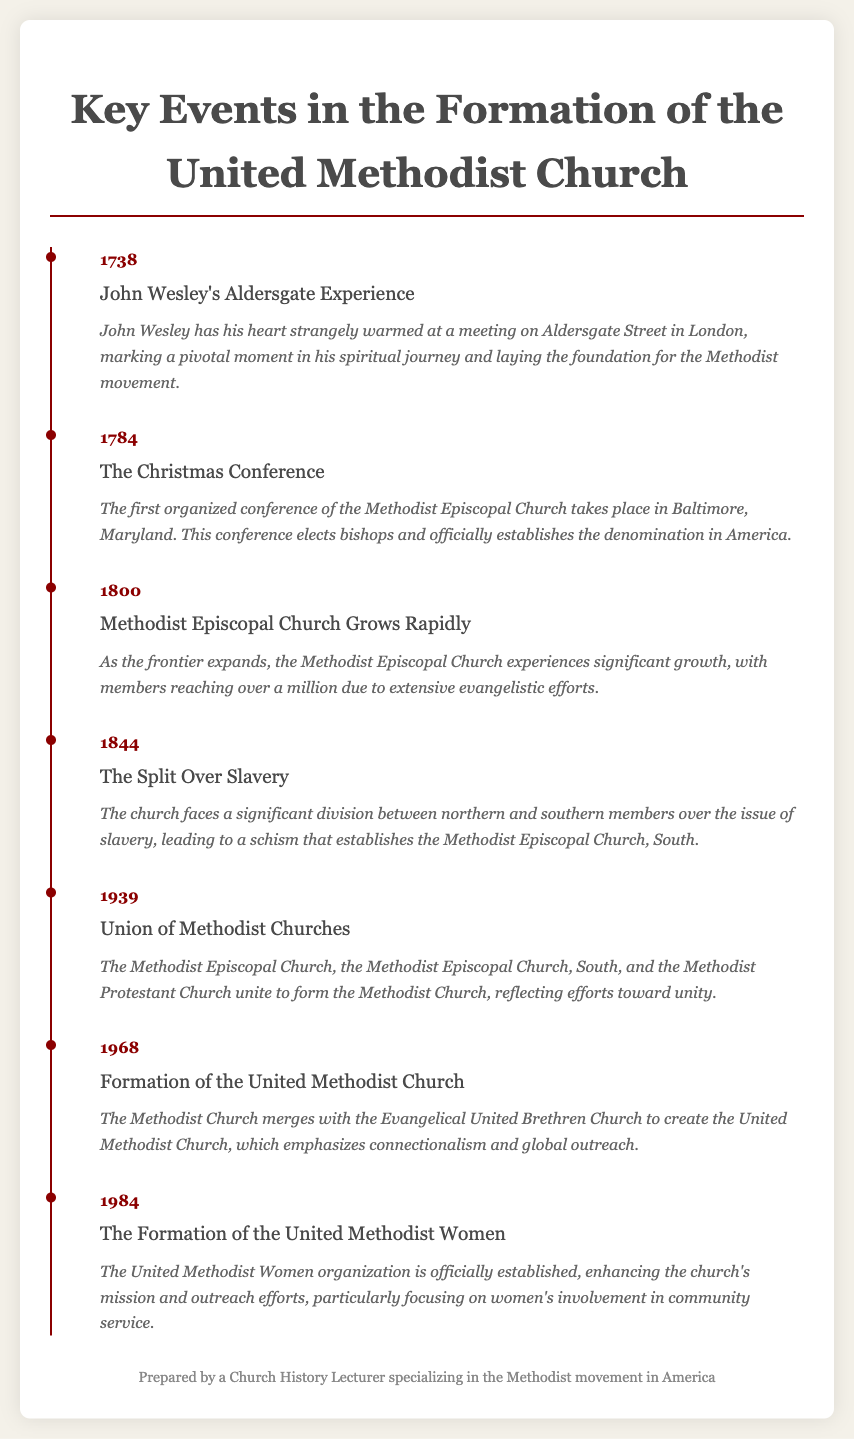What year did John Wesley have his Aldersgate Experience? The document states that John Wesley's Aldersgate Experience took place in 1738.
Answer: 1738 What was established during the Christmas Conference? The document indicates that the Christmas Conference officially establishes the denomination in America and elects bishops.
Answer: The denomination What significant social issue caused a split in the church in 1844? The document highlights that the division between northern and southern members was over the issue of slavery.
Answer: Slavery What year was the United Methodist Women officially established? According to the document, the United Methodist Women organization was established in 1984.
Answer: 1984 How many members did the Methodist Episcopal Church reach by 1800? The document mentions that membership reached over a million due to evangelistic efforts by 1800.
Answer: Over a million What is the significance of the year 1968? The document states that in 1968, the Methodist Church merged with the Evangelical United Brethren Church to create the United Methodist Church.
Answer: Formation of the United Methodist Church Which three churches united in 1939? The document lists the churches that united as the Methodist Episcopal Church, the Methodist Episcopal Church, South, and the Methodist Protestant Church.
Answer: Three churches What does the timeline organization of the document highlight? The document’s timeline organization highlights the chronological order of key events in the formation of the United Methodist Church.
Answer: Chronological order 